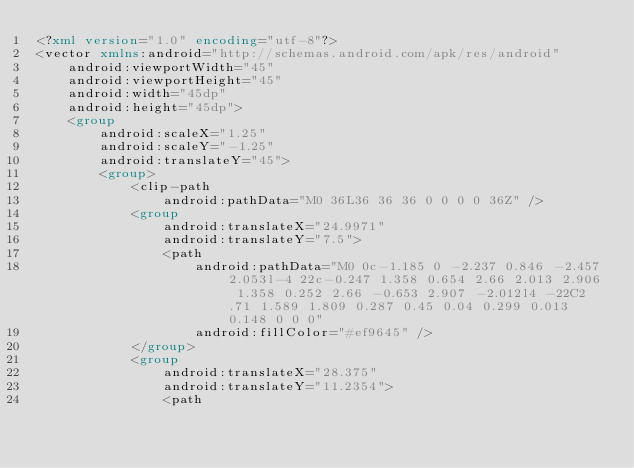<code> <loc_0><loc_0><loc_500><loc_500><_XML_><?xml version="1.0" encoding="utf-8"?>
<vector xmlns:android="http://schemas.android.com/apk/res/android"
    android:viewportWidth="45"
    android:viewportHeight="45"
    android:width="45dp"
    android:height="45dp">
    <group
        android:scaleX="1.25"
        android:scaleY="-1.25"
        android:translateY="45">
        <group>
            <clip-path
                android:pathData="M0 36L36 36 36 0 0 0 0 36Z" />
            <group
                android:translateX="24.9971"
                android:translateY="7.5">
                <path
                    android:pathData="M0 0c-1.185 0 -2.237 0.846 -2.457 2.053l-4 22c-0.247 1.358 0.654 2.66 2.013 2.906 1.358 0.252 2.66 -0.653 2.907 -2.012l4 -22C2.71 1.589 1.809 0.287 0.45 0.04 0.299 0.013 0.148 0 0 0"
                    android:fillColor="#ef9645" />
            </group>
            <group
                android:translateX="28.375"
                android:translateY="11.2354">
                <path</code> 